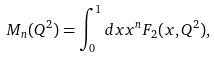<formula> <loc_0><loc_0><loc_500><loc_500>M _ { n } ( Q ^ { 2 } ) = \int _ { 0 } ^ { 1 } d x x ^ { n } F _ { 2 } ( x , Q ^ { 2 } ) ,</formula> 